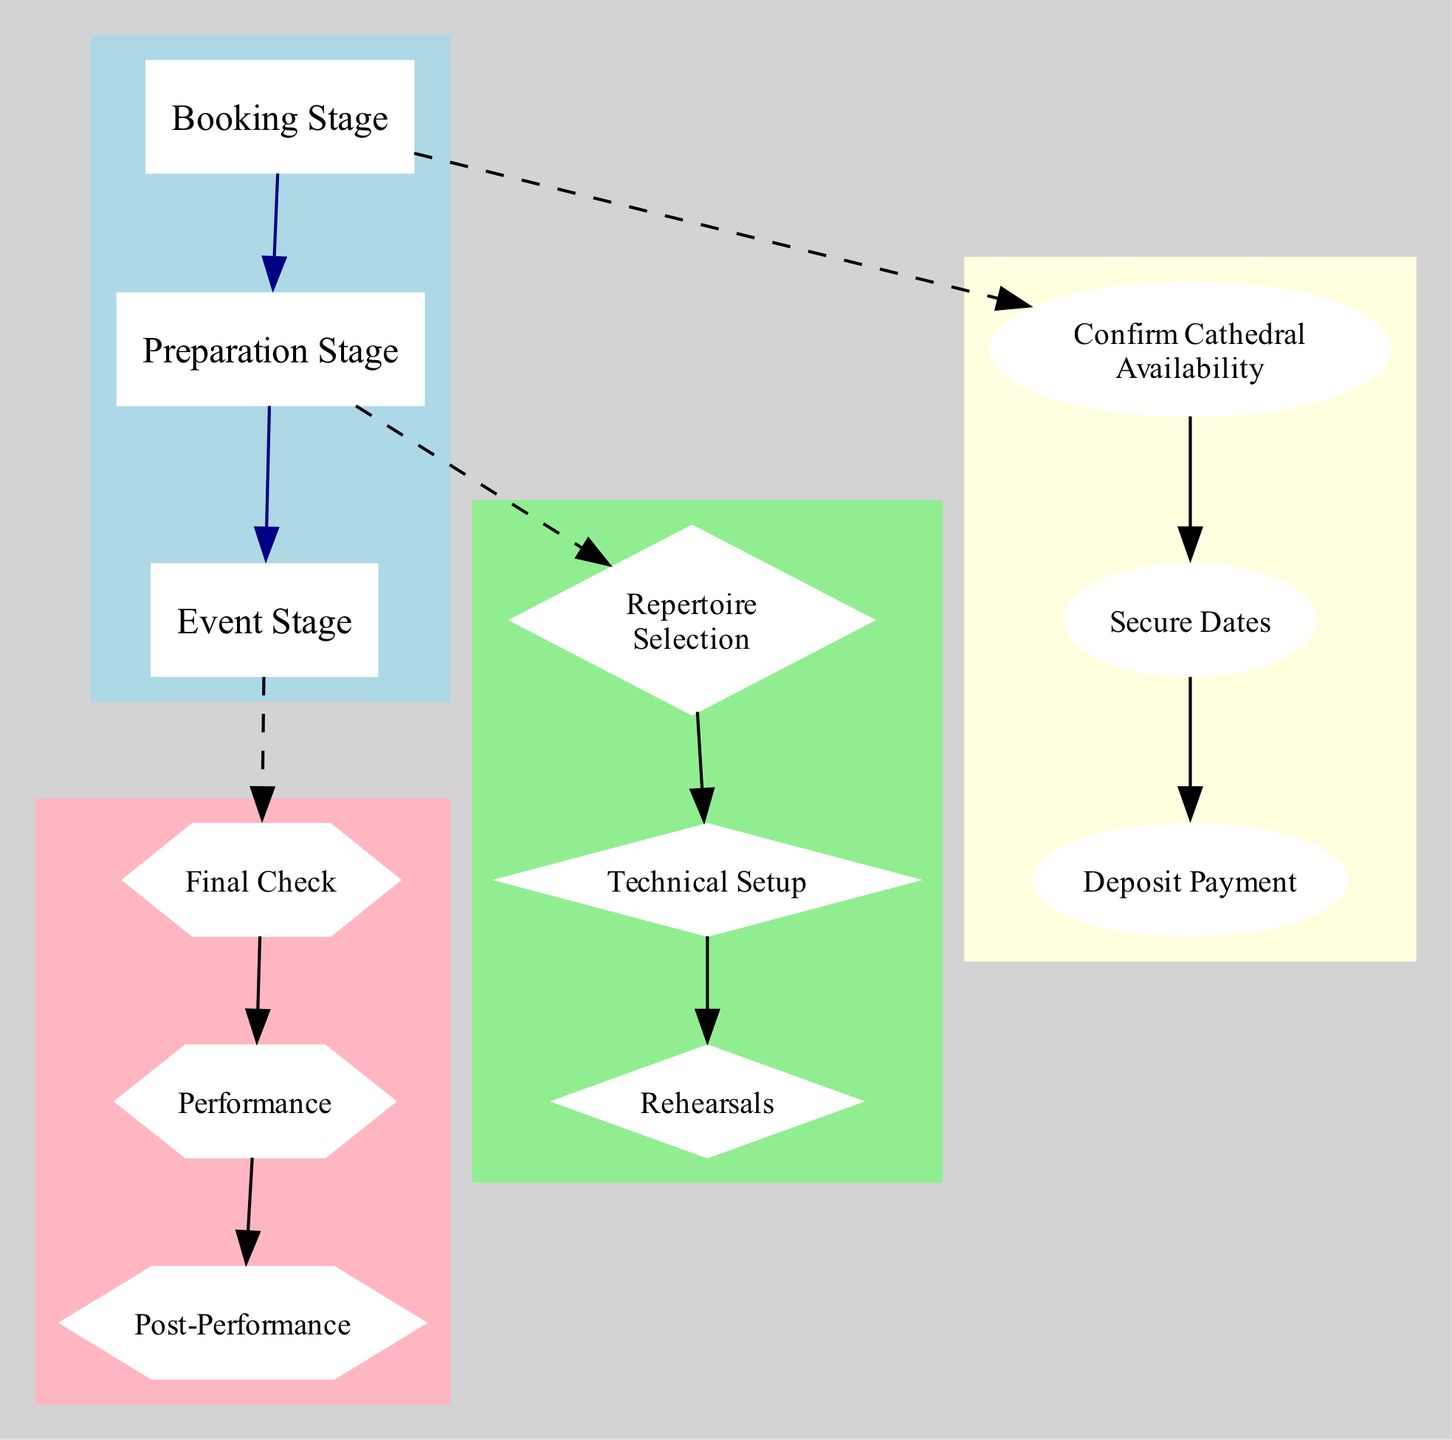What is the confirmed date for the concert? The confirmed date in the diagram is explicitly stated under the "Secure Dates" node in the Booking Stage as "2023-06-05."
Answer: 2023-06-05 Who is the contact person for confirming cathedral availability? The contact person is indicated under the "Confirm Cathedral Availability" node in the Booking Stage as "Father Jean Dupont."
Answer: Father Jean Dupont How many rehearsal dates are planned? The number of rehearsal dates can be counted from the "dates" listed under the "Rehearsals" node in the Preparation Stage, which are "2023-06-03" and "2023-06-04." This shows there are two dates.
Answer: 2 What equipment is rented from Cathedral Acoustics Ltd.? The equipment can be found listed under the "equipmentRental" section in the Technical Setup. The items include "Microphones," "Stereo Recording System," and "Portable Organ."
Answer: Microphones, Stereo Recording System, Portable Organ What is the total amount to be paid after the performance? The amount for payment settlement is specified in the "paymentSettlement" section under the Post-Performance node, which states the final amount is "1000 EUR."
Answer: 1000 EUR Which stage comes after the Preparation Stage? The diagram shows the sequential flow from the nodes, indicating that the Event Stage follows the Preparation Stage.
Answer: Event Stage When is the sound check scheduled? The sound check time is defined within the "Final Check" node in the Event Stage as "2023-06-05 10:00."
Answer: 2023-06-05 10:00 What is the deadline for equipment return? The deadline for equipment return is noted under the "PostPerformance" node, specifically in the "equipmentReturn" section as "2023-06-06 12:00."
Answer: 2023-06-06 12:00 What type of node represents the Repertoire Selection? The Repertoire Selection node is categorized under the Preparation Stage, and its visual representation is marked as a diamond shape in the diagram.
Answer: Diamond 